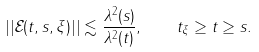<formula> <loc_0><loc_0><loc_500><loc_500>| | \mathcal { E } ( t , s , \xi ) | | \lesssim \frac { \lambda ^ { 2 } ( s ) } { \lambda ^ { 2 } ( t ) } , \quad t _ { \xi } \geq t \geq s .</formula> 